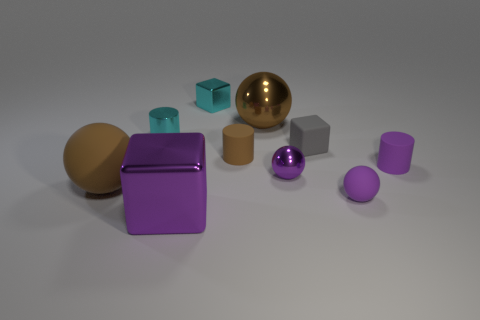What material is the sphere that is behind the tiny brown object?
Your answer should be very brief. Metal. What number of things are big brown objects that are to the left of the small brown cylinder or tiny yellow shiny cubes?
Offer a very short reply. 1. What number of other things are there of the same shape as the tiny gray thing?
Your response must be concise. 2. There is a big brown thing in front of the tiny brown cylinder; is it the same shape as the small purple shiny thing?
Offer a very short reply. Yes. There is a small purple rubber ball; are there any cyan metallic cylinders in front of it?
Your response must be concise. No. What number of small objects are purple metal objects or purple objects?
Give a very brief answer. 3. Do the gray cube and the tiny purple cylinder have the same material?
Offer a terse response. Yes. What size is the cylinder that is the same color as the small shiny cube?
Provide a succinct answer. Small. Are there any tiny things of the same color as the shiny cylinder?
Keep it short and to the point. Yes. What is the size of the brown object that is made of the same material as the large purple block?
Your answer should be very brief. Large. 